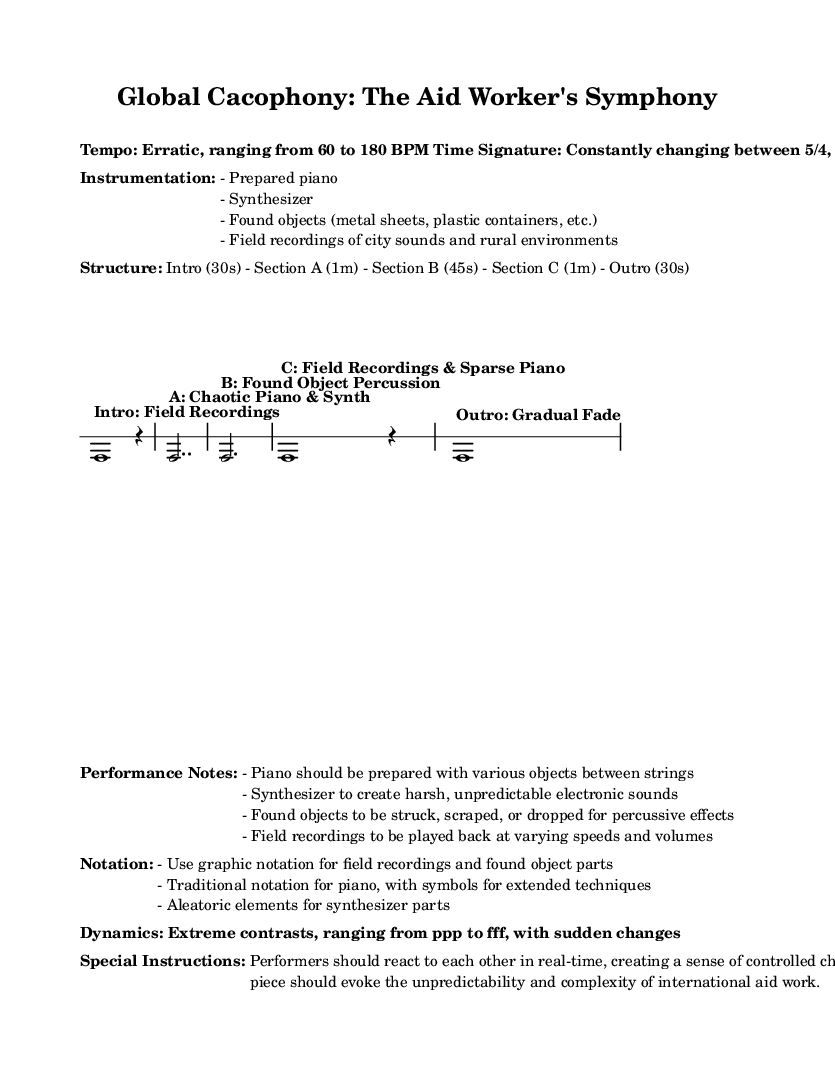What is the tempo range of this piece? The tempo markings indicate an erratic range, specifically from 60 to 180 BPM. This information is explicitly noted under the "Tempo" section.
Answer: 60 to 180 BPM What are the time signatures used in this music? The piece features changing time signatures: it starts with 5/4, moves to 7/8, then to 3/4, and returns to 5/4 for the Outro. This is derived from the markings above different sections in the score.
Answer: 5/4, 7/8, 3/4 What kind of instrumentation is used? The instrumentation includes a prepared piano, synthesizer, found objects, and field recordings. This is listed in the "Instrumentation" section and clearly defines the types of sounds to be used in the performance.
Answer: Prepared piano, synthesizer, found objects, field recordings What unique performance technique is suggested for the piano? The performance notes suggest that the piano be prepared with various objects between the strings, which will alter the sound produced by the instrument. This is directly specified in the "Performance Notes" section.
Answer: Prepared with various objects How long is Section B of the piece? Section B is indicated to last for 45 seconds, which is directly stated in the "Structure" section of the sheet music.
Answer: 45 seconds What element introduces an unpredictable aspect to the synthesizer parts? The synthesizer parts are described as having aleatoric elements, which refers to a degree of chance or randomness introduced in the performance. This is detailed in the "Notation" section.
Answer: Aleatoric elements What dynamics contrasts are specified in the performance? The piece encompasses extreme contrasts in dynamics, ranging from ppp (pianississimo) to fff (fortississimo), indicating very soft to very loud sounds. This is mentioned in the "Dynamics" section.
Answer: Extreme contrasts, ppp to fff 